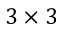<formula> <loc_0><loc_0><loc_500><loc_500>3 \times 3</formula> 